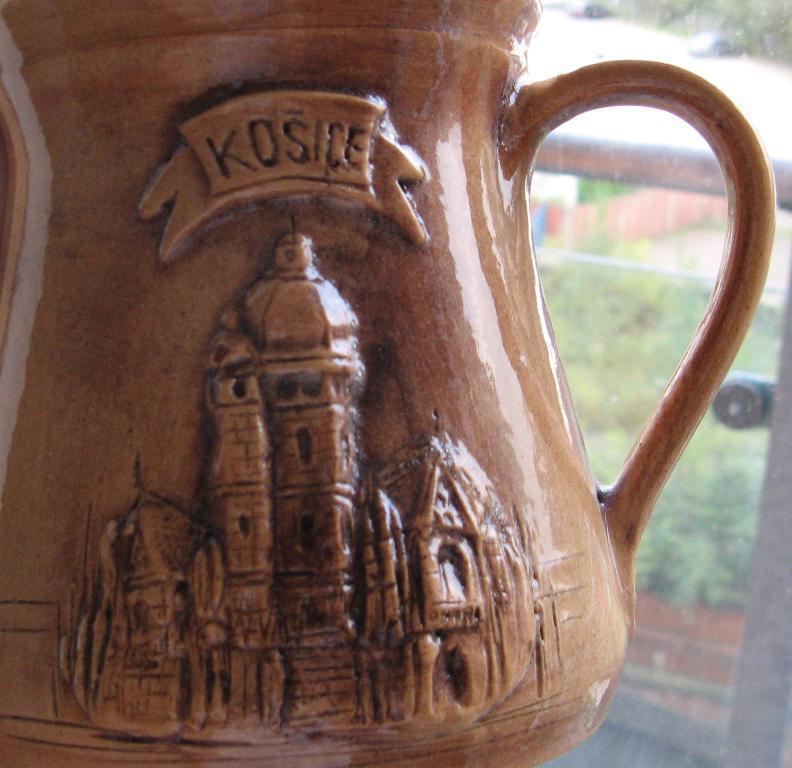Describe this image in one or two sentences. This image consists of a mug made up of ceramic. It is in brown color. In the background, there is a window. 